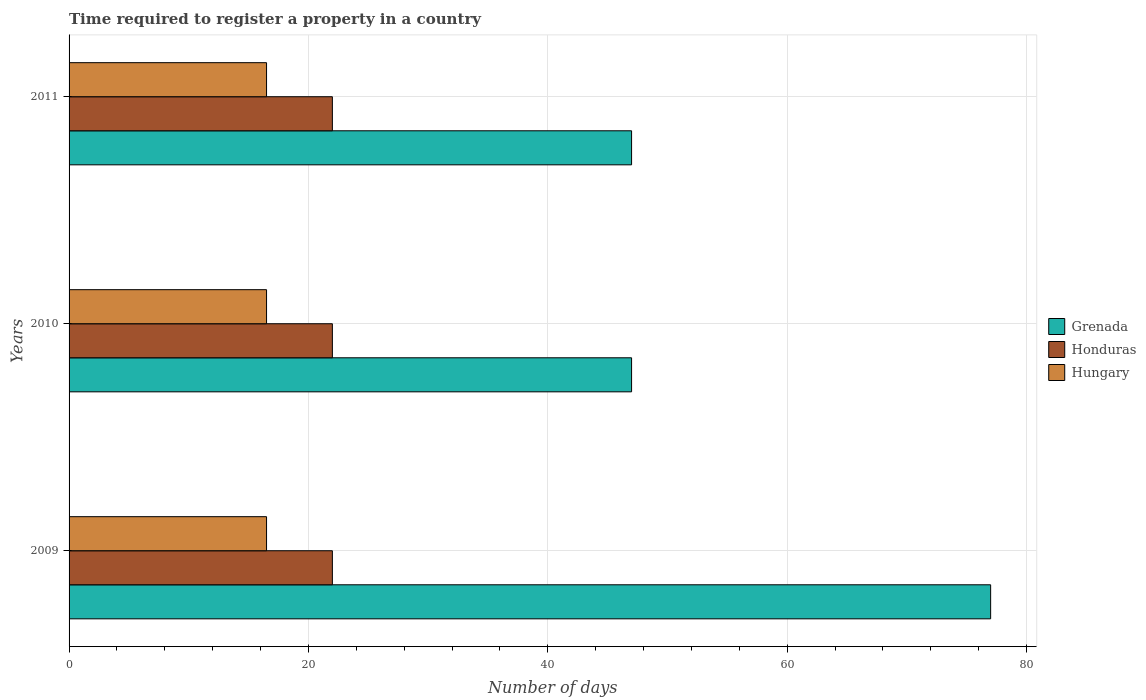How many bars are there on the 3rd tick from the bottom?
Your response must be concise. 3. What is the number of days required to register a property in Hungary in 2009?
Offer a very short reply. 16.5. What is the total number of days required to register a property in Grenada in the graph?
Make the answer very short. 171. What is the difference between the number of days required to register a property in Grenada in 2010 and the number of days required to register a property in Hungary in 2011?
Ensure brevity in your answer.  30.5. In the year 2010, what is the difference between the number of days required to register a property in Hungary and number of days required to register a property in Grenada?
Your answer should be compact. -30.5. What is the ratio of the number of days required to register a property in Honduras in 2009 to that in 2010?
Give a very brief answer. 1. What does the 2nd bar from the top in 2009 represents?
Your answer should be very brief. Honduras. What does the 3rd bar from the bottom in 2010 represents?
Provide a succinct answer. Hungary. How many bars are there?
Your response must be concise. 9. Are all the bars in the graph horizontal?
Provide a succinct answer. Yes. How many years are there in the graph?
Your response must be concise. 3. What is the difference between two consecutive major ticks on the X-axis?
Make the answer very short. 20. Are the values on the major ticks of X-axis written in scientific E-notation?
Provide a succinct answer. No. Does the graph contain grids?
Offer a very short reply. Yes. Where does the legend appear in the graph?
Your response must be concise. Center right. How many legend labels are there?
Provide a succinct answer. 3. What is the title of the graph?
Offer a very short reply. Time required to register a property in a country. What is the label or title of the X-axis?
Ensure brevity in your answer.  Number of days. What is the label or title of the Y-axis?
Provide a succinct answer. Years. What is the Number of days of Grenada in 2009?
Your answer should be compact. 77. What is the Number of days in Honduras in 2009?
Provide a succinct answer. 22. What is the Number of days in Honduras in 2011?
Keep it short and to the point. 22. Across all years, what is the maximum Number of days of Grenada?
Provide a succinct answer. 77. What is the total Number of days of Grenada in the graph?
Your answer should be very brief. 171. What is the total Number of days in Honduras in the graph?
Ensure brevity in your answer.  66. What is the total Number of days of Hungary in the graph?
Keep it short and to the point. 49.5. What is the difference between the Number of days of Grenada in 2009 and that in 2010?
Offer a terse response. 30. What is the difference between the Number of days in Honduras in 2009 and that in 2010?
Ensure brevity in your answer.  0. What is the difference between the Number of days of Hungary in 2009 and that in 2010?
Give a very brief answer. 0. What is the difference between the Number of days of Grenada in 2009 and that in 2011?
Keep it short and to the point. 30. What is the difference between the Number of days in Honduras in 2009 and that in 2011?
Make the answer very short. 0. What is the difference between the Number of days of Honduras in 2010 and that in 2011?
Your answer should be very brief. 0. What is the difference between the Number of days of Hungary in 2010 and that in 2011?
Provide a succinct answer. 0. What is the difference between the Number of days of Grenada in 2009 and the Number of days of Honduras in 2010?
Your answer should be very brief. 55. What is the difference between the Number of days in Grenada in 2009 and the Number of days in Hungary in 2010?
Ensure brevity in your answer.  60.5. What is the difference between the Number of days of Grenada in 2009 and the Number of days of Hungary in 2011?
Offer a very short reply. 60.5. What is the difference between the Number of days in Grenada in 2010 and the Number of days in Honduras in 2011?
Your answer should be very brief. 25. What is the difference between the Number of days in Grenada in 2010 and the Number of days in Hungary in 2011?
Provide a succinct answer. 30.5. What is the average Number of days in Hungary per year?
Ensure brevity in your answer.  16.5. In the year 2009, what is the difference between the Number of days in Grenada and Number of days in Hungary?
Offer a very short reply. 60.5. In the year 2009, what is the difference between the Number of days of Honduras and Number of days of Hungary?
Make the answer very short. 5.5. In the year 2010, what is the difference between the Number of days in Grenada and Number of days in Hungary?
Ensure brevity in your answer.  30.5. In the year 2010, what is the difference between the Number of days in Honduras and Number of days in Hungary?
Offer a very short reply. 5.5. In the year 2011, what is the difference between the Number of days in Grenada and Number of days in Hungary?
Your response must be concise. 30.5. In the year 2011, what is the difference between the Number of days of Honduras and Number of days of Hungary?
Ensure brevity in your answer.  5.5. What is the ratio of the Number of days in Grenada in 2009 to that in 2010?
Give a very brief answer. 1.64. What is the ratio of the Number of days of Honduras in 2009 to that in 2010?
Your response must be concise. 1. What is the ratio of the Number of days of Hungary in 2009 to that in 2010?
Provide a succinct answer. 1. What is the ratio of the Number of days of Grenada in 2009 to that in 2011?
Offer a terse response. 1.64. What is the ratio of the Number of days in Honduras in 2009 to that in 2011?
Offer a terse response. 1. What is the ratio of the Number of days in Grenada in 2010 to that in 2011?
Offer a very short reply. 1. What is the difference between the highest and the second highest Number of days of Hungary?
Provide a succinct answer. 0. What is the difference between the highest and the lowest Number of days in Grenada?
Provide a short and direct response. 30. 